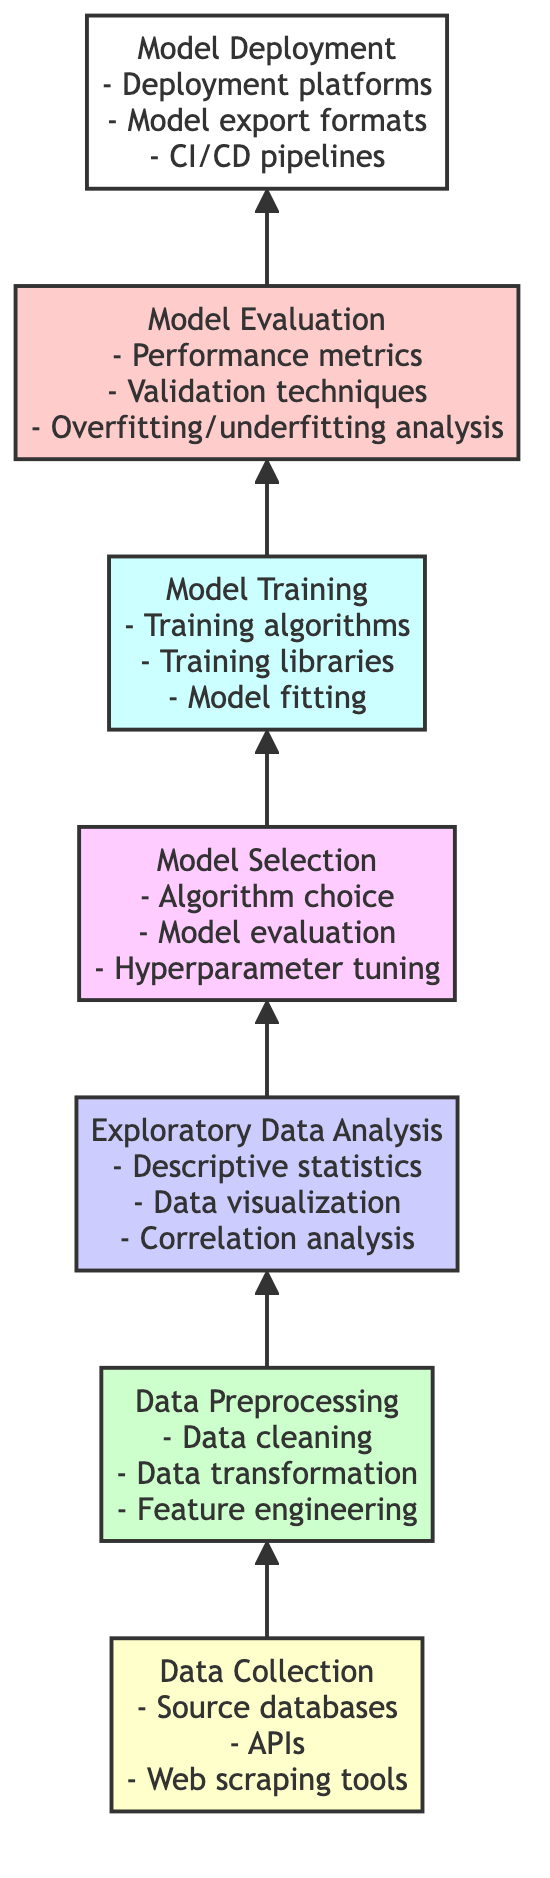What is the first step in the predictive model development process? The diagram shows "Data Collection" at the bottom, indicating that this is the starting point in the process of predictive model development.
Answer: Data Collection How many levels are in the diagram? By counting the different stages from "Data Collection" at the bottom to "Model Deployment" at the top, we see there are seven distinct levels.
Answer: Seven What is the last step in the predictive model development process? The last step, as shown at the top of the diagram, is "Model Deployment," which indicates where the model is ultimately put into use.
Answer: Model Deployment What comes directly after "Model Training"? "Model Evaluation" follows "Model Training" in the flow, as indicated by the arrow pointing upward, showing the sequence of steps in the process.
Answer: Model Evaluation Which stage includes "Feature engineering"? "Feature engineering" is mentioned in the "Data Preprocessing" stage, indicating that this activity happens after data collection but before exploratory data analysis.
Answer: Data Preprocessing Which techniques are used in "Model Evaluation"? The diagram lists "performance metrics," "validation techniques," and "overfitting/underfitting analysis" as part of the activities involved in the "Model Evaluation" stage.
Answer: Performance metrics, validation techniques, overfitting/underfitting analysis What is the relationship between "Exploratory Data Analysis" and "Model Selection"? The diagram indicates that "Exploratory Data Analysis" precedes "Model Selection" in the process, meaning the insights gained from data exploration inform the model selection process.
Answer: Exploratory Data Analysis precedes Model Selection How many specific tools are mentioned under "Data Collection"? The details under "Data Collection" specify three tools: source databases, APIs, and web scraping tools, confirming that there are three distinct tools mentioned.
Answer: Three What is the primary focus of "Model Selection"? "Model Selection" primarily focuses on choosing the appropriate algorithm, evaluating the model, and fine-tuning hyperparameters to optimize model performance.
Answer: Choosing the algorithm, evaluating the model, hyperparameter tuning In which stage would you handle missing values? Handling missing values is a key task associated with "Data Preprocessing," as this is the stage where data cleaning occurs to prepare data for analysis.
Answer: Data Preprocessing 